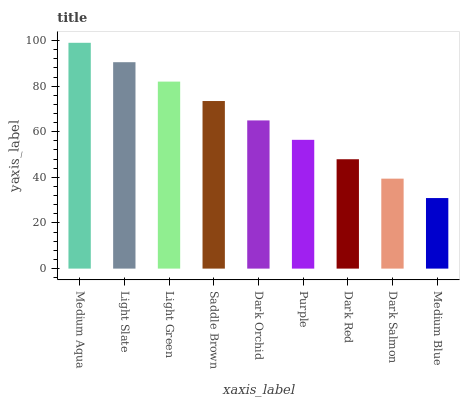Is Medium Blue the minimum?
Answer yes or no. Yes. Is Medium Aqua the maximum?
Answer yes or no. Yes. Is Light Slate the minimum?
Answer yes or no. No. Is Light Slate the maximum?
Answer yes or no. No. Is Medium Aqua greater than Light Slate?
Answer yes or no. Yes. Is Light Slate less than Medium Aqua?
Answer yes or no. Yes. Is Light Slate greater than Medium Aqua?
Answer yes or no. No. Is Medium Aqua less than Light Slate?
Answer yes or no. No. Is Dark Orchid the high median?
Answer yes or no. Yes. Is Dark Orchid the low median?
Answer yes or no. Yes. Is Medium Aqua the high median?
Answer yes or no. No. Is Light Green the low median?
Answer yes or no. No. 